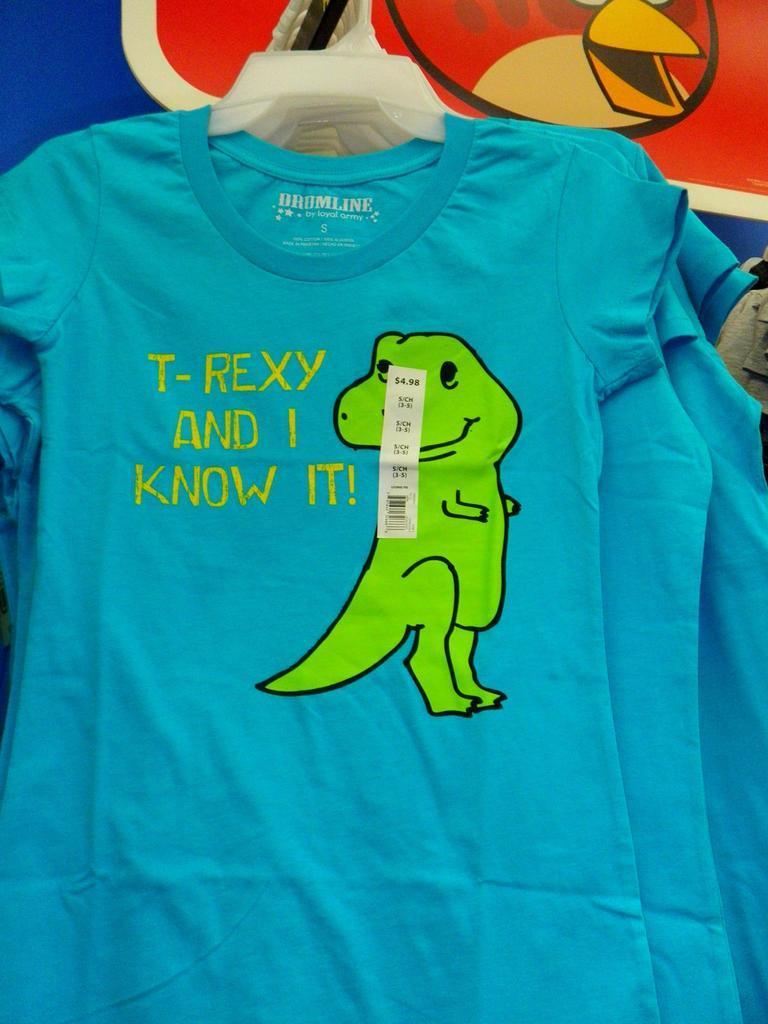How would you summarize this image in a sentence or two? In this image we can see blue t-shirts, hanging to the hanger, there is a green cartoon on it. 